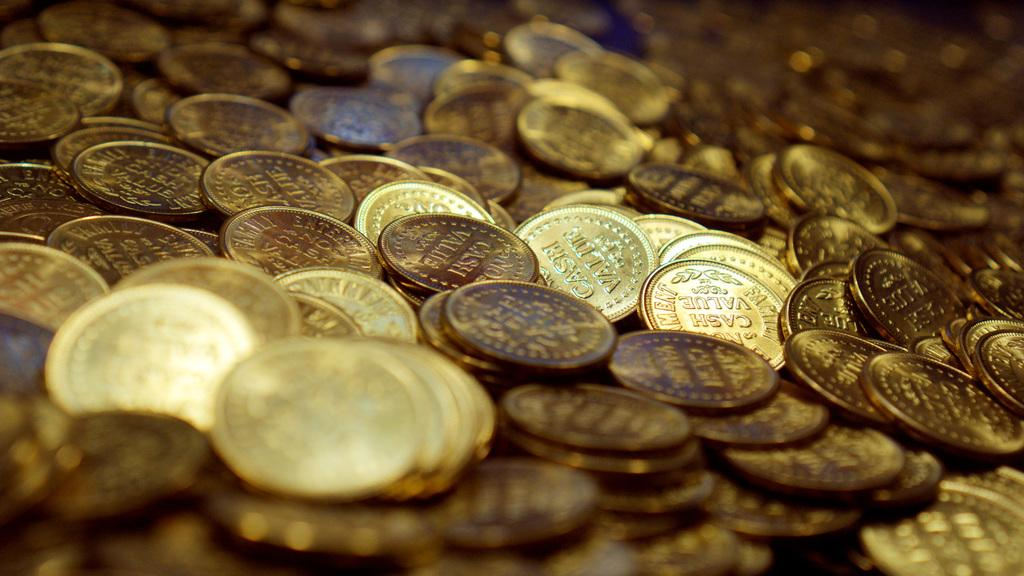<image>
Offer a succinct explanation of the picture presented. A pile of coins with engrave that says "No Cash Value". 